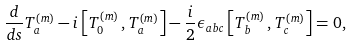Convert formula to latex. <formula><loc_0><loc_0><loc_500><loc_500>\frac { d } { d s } T _ { a } ^ { ( m ) } - i \left [ T ^ { ( m ) } _ { 0 } \, , T ^ { ( m ) } _ { a } \right ] - \frac { i } { 2 } \epsilon _ { a b c } \left [ T ^ { ( m ) } _ { b } \, , T ^ { ( m ) } _ { c } \right ] = 0 ,</formula> 